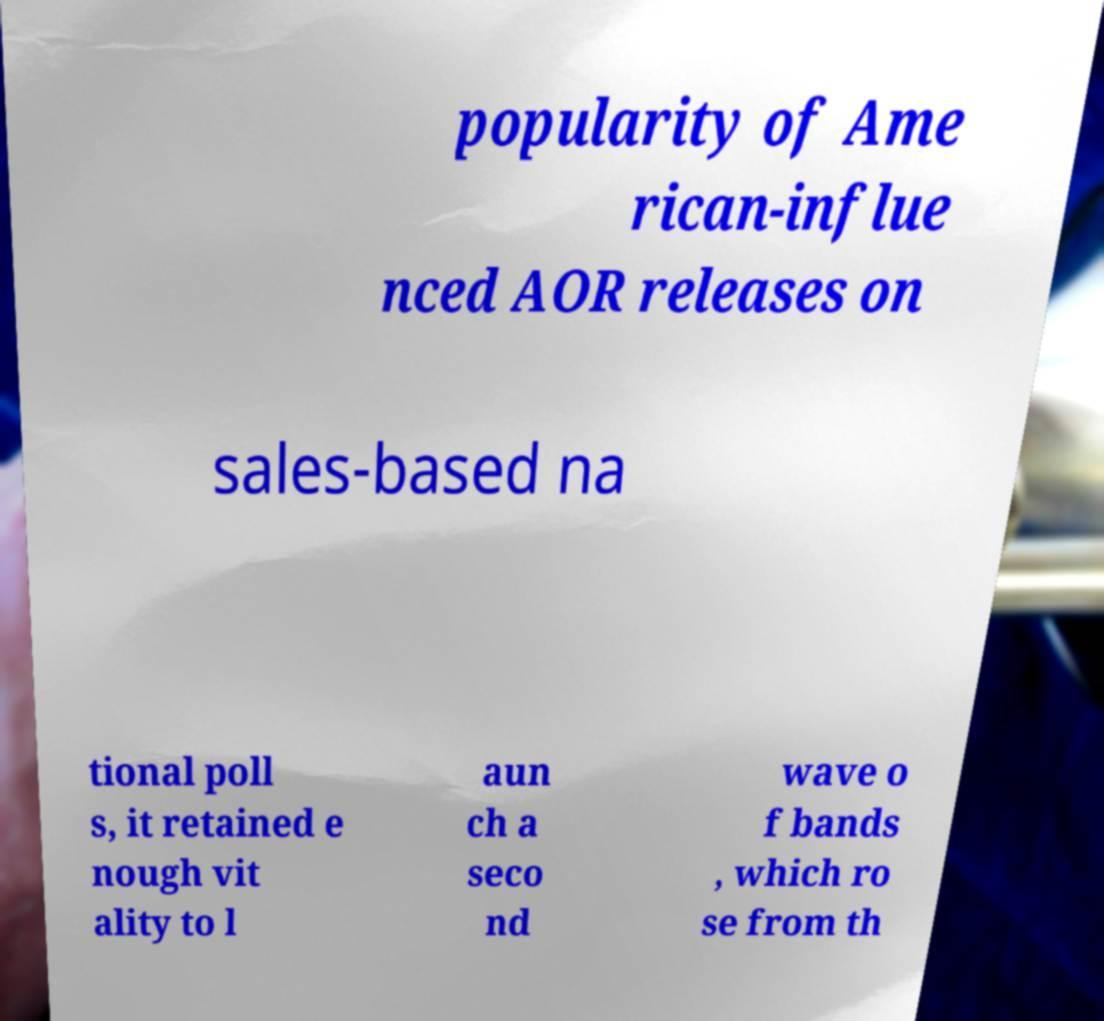There's text embedded in this image that I need extracted. Can you transcribe it verbatim? popularity of Ame rican-influe nced AOR releases on sales-based na tional poll s, it retained e nough vit ality to l aun ch a seco nd wave o f bands , which ro se from th 